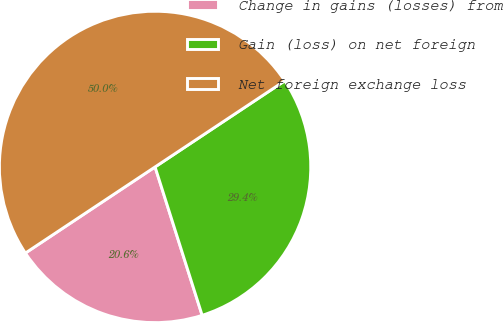Convert chart. <chart><loc_0><loc_0><loc_500><loc_500><pie_chart><fcel>Change in gains (losses) from<fcel>Gain (loss) on net foreign<fcel>Net foreign exchange loss<nl><fcel>20.56%<fcel>29.44%<fcel>50.0%<nl></chart> 